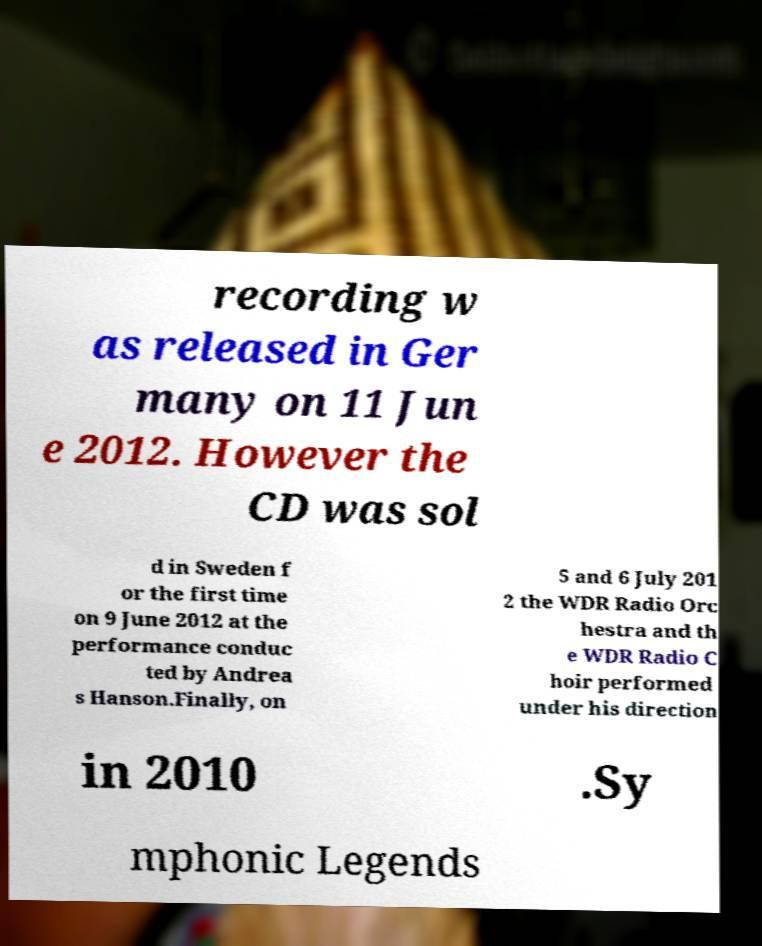Could you assist in decoding the text presented in this image and type it out clearly? recording w as released in Ger many on 11 Jun e 2012. However the CD was sol d in Sweden f or the first time on 9 June 2012 at the performance conduc ted by Andrea s Hanson.Finally, on 5 and 6 July 201 2 the WDR Radio Orc hestra and th e WDR Radio C hoir performed under his direction in 2010 .Sy mphonic Legends 